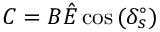Convert formula to latex. <formula><loc_0><loc_0><loc_500><loc_500>C = B \hat { E } \cos { ( \delta _ { s } ^ { \circ } ) }</formula> 